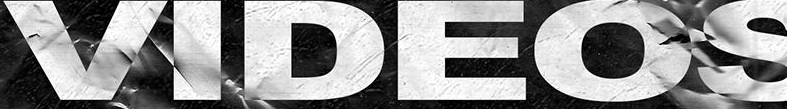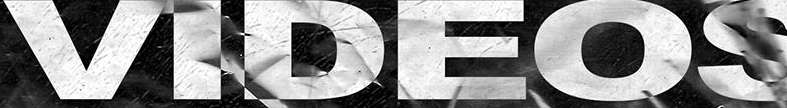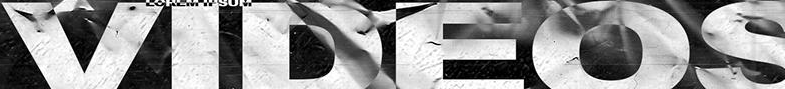What words can you see in these images in sequence, separated by a semicolon? VIDEOS; VIDEOS; VIDEOS 